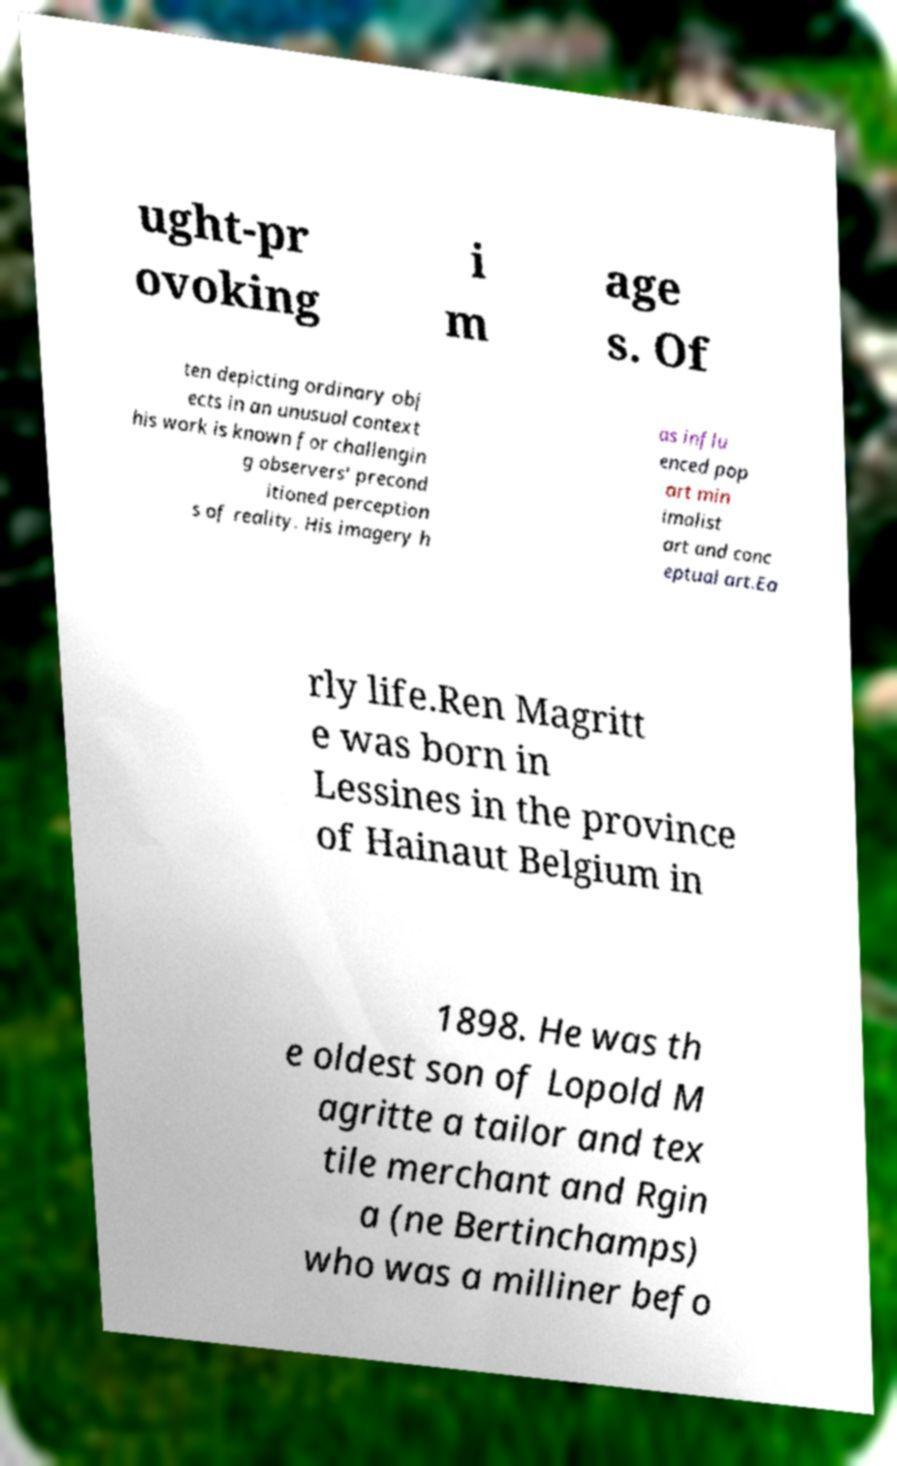Please read and relay the text visible in this image. What does it say? ught-pr ovoking i m age s. Of ten depicting ordinary obj ects in an unusual context his work is known for challengin g observers' precond itioned perception s of reality. His imagery h as influ enced pop art min imalist art and conc eptual art.Ea rly life.Ren Magritt e was born in Lessines in the province of Hainaut Belgium in 1898. He was th e oldest son of Lopold M agritte a tailor and tex tile merchant and Rgin a (ne Bertinchamps) who was a milliner befo 